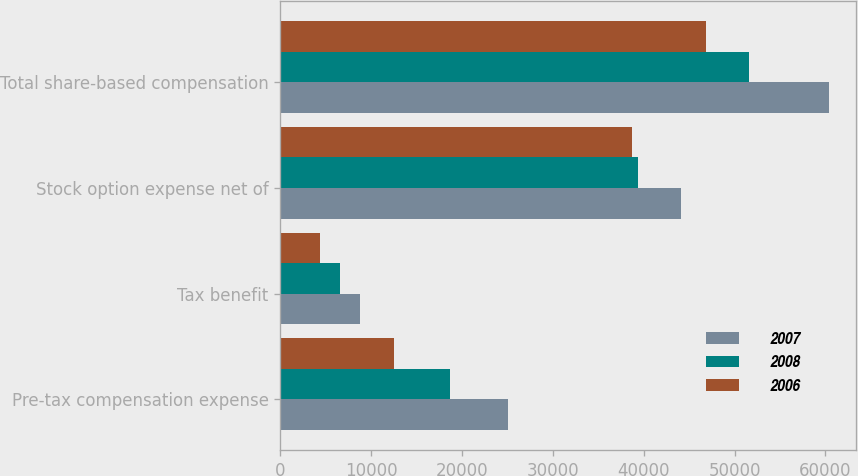<chart> <loc_0><loc_0><loc_500><loc_500><stacked_bar_chart><ecel><fcel>Pre-tax compensation expense<fcel>Tax benefit<fcel>Stock option expense net of<fcel>Total share-based compensation<nl><fcel>2007<fcel>25109<fcel>8789<fcel>44057<fcel>60377<nl><fcel>2008<fcel>18708<fcel>6548<fcel>39386<fcel>51546<nl><fcel>2006<fcel>12561<fcel>4396<fcel>38689<fcel>46854<nl></chart> 